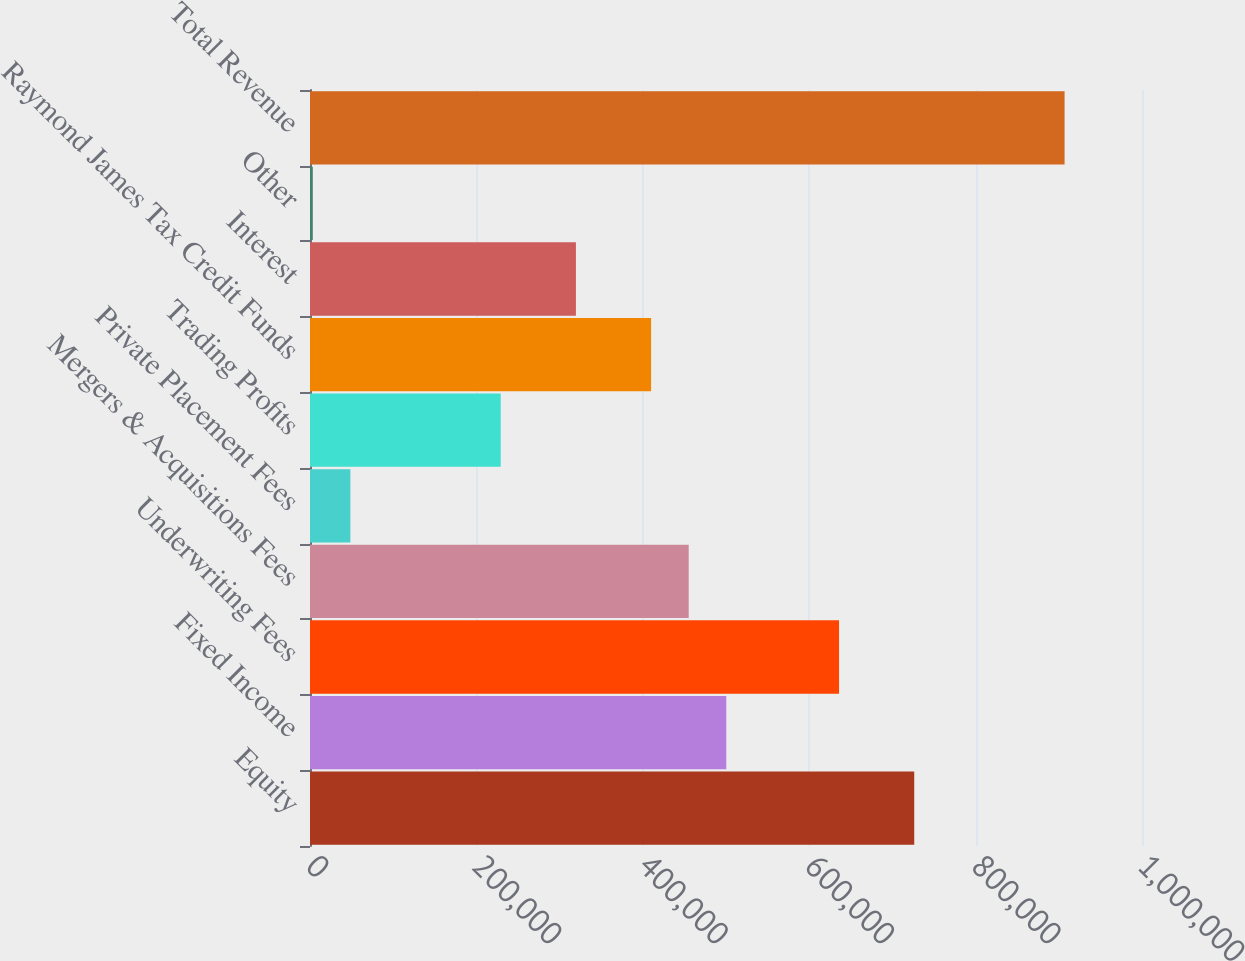Convert chart to OTSL. <chart><loc_0><loc_0><loc_500><loc_500><bar_chart><fcel>Equity<fcel>Fixed Income<fcel>Underwriting Fees<fcel>Mergers & Acquisitions Fees<fcel>Private Placement Fees<fcel>Trading Profits<fcel>Raymond James Tax Credit Funds<fcel>Interest<fcel>Other<fcel>Total Revenue<nl><fcel>726238<fcel>500332<fcel>635876<fcel>455151<fcel>48520.2<fcel>229245<fcel>409970<fcel>319607<fcel>3339<fcel>906963<nl></chart> 